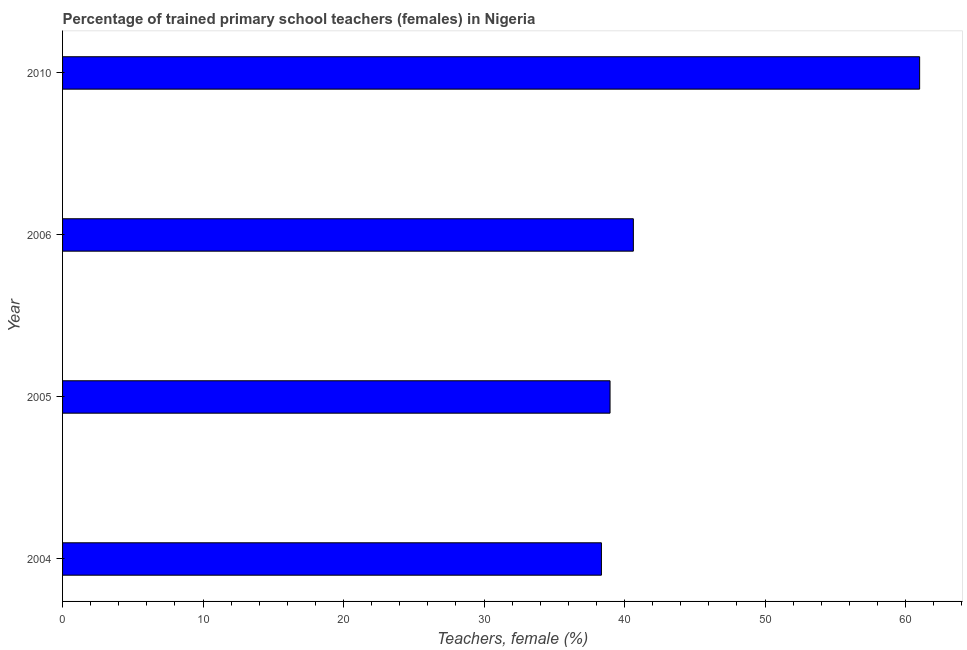What is the title of the graph?
Offer a terse response. Percentage of trained primary school teachers (females) in Nigeria. What is the label or title of the X-axis?
Ensure brevity in your answer.  Teachers, female (%). What is the percentage of trained female teachers in 2005?
Provide a short and direct response. 38.97. Across all years, what is the maximum percentage of trained female teachers?
Provide a succinct answer. 61.01. Across all years, what is the minimum percentage of trained female teachers?
Provide a succinct answer. 38.36. In which year was the percentage of trained female teachers maximum?
Provide a short and direct response. 2010. In which year was the percentage of trained female teachers minimum?
Your answer should be very brief. 2004. What is the sum of the percentage of trained female teachers?
Ensure brevity in your answer.  178.96. What is the difference between the percentage of trained female teachers in 2004 and 2010?
Your response must be concise. -22.65. What is the average percentage of trained female teachers per year?
Your answer should be compact. 44.74. What is the median percentage of trained female teachers?
Offer a terse response. 39.8. What is the ratio of the percentage of trained female teachers in 2004 to that in 2010?
Ensure brevity in your answer.  0.63. Is the percentage of trained female teachers in 2005 less than that in 2006?
Your answer should be compact. Yes. What is the difference between the highest and the second highest percentage of trained female teachers?
Provide a short and direct response. 20.38. What is the difference between the highest and the lowest percentage of trained female teachers?
Your answer should be very brief. 22.65. How many years are there in the graph?
Make the answer very short. 4. What is the Teachers, female (%) of 2004?
Offer a very short reply. 38.36. What is the Teachers, female (%) in 2005?
Make the answer very short. 38.97. What is the Teachers, female (%) in 2006?
Give a very brief answer. 40.63. What is the Teachers, female (%) of 2010?
Give a very brief answer. 61.01. What is the difference between the Teachers, female (%) in 2004 and 2005?
Keep it short and to the point. -0.61. What is the difference between the Teachers, female (%) in 2004 and 2006?
Your answer should be compact. -2.27. What is the difference between the Teachers, female (%) in 2004 and 2010?
Ensure brevity in your answer.  -22.65. What is the difference between the Teachers, female (%) in 2005 and 2006?
Offer a terse response. -1.66. What is the difference between the Teachers, female (%) in 2005 and 2010?
Make the answer very short. -22.04. What is the difference between the Teachers, female (%) in 2006 and 2010?
Offer a terse response. -20.38. What is the ratio of the Teachers, female (%) in 2004 to that in 2005?
Give a very brief answer. 0.98. What is the ratio of the Teachers, female (%) in 2004 to that in 2006?
Provide a short and direct response. 0.94. What is the ratio of the Teachers, female (%) in 2004 to that in 2010?
Ensure brevity in your answer.  0.63. What is the ratio of the Teachers, female (%) in 2005 to that in 2006?
Offer a terse response. 0.96. What is the ratio of the Teachers, female (%) in 2005 to that in 2010?
Your response must be concise. 0.64. What is the ratio of the Teachers, female (%) in 2006 to that in 2010?
Provide a short and direct response. 0.67. 